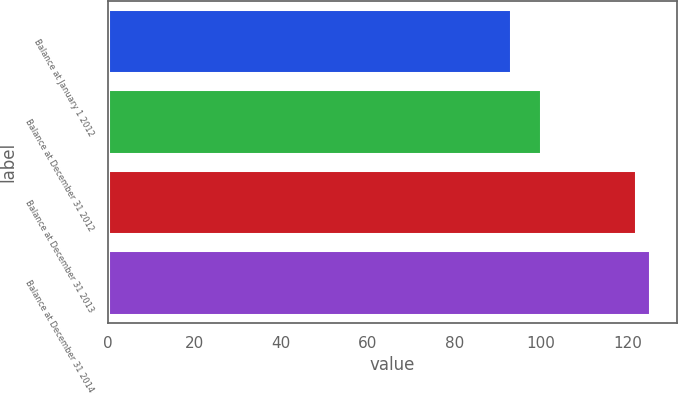<chart> <loc_0><loc_0><loc_500><loc_500><bar_chart><fcel>Balance at January 1 2012<fcel>Balance at December 31 2012<fcel>Balance at December 31 2013<fcel>Balance at December 31 2014<nl><fcel>93<fcel>100<fcel>122<fcel>125.2<nl></chart> 